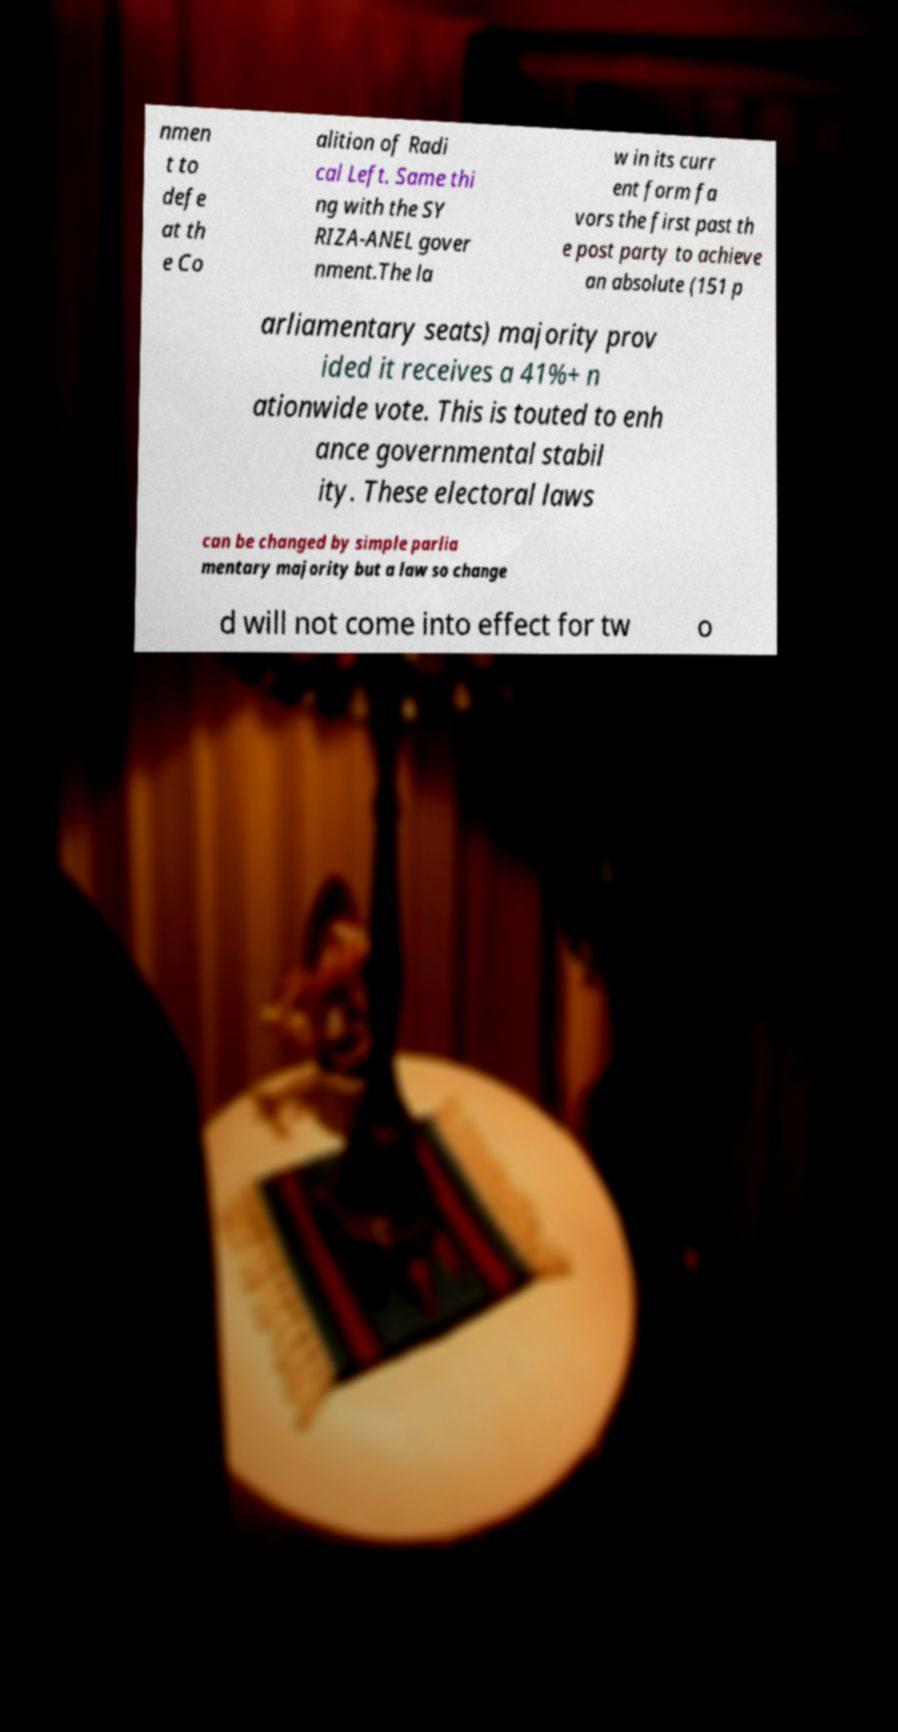Could you assist in decoding the text presented in this image and type it out clearly? nmen t to defe at th e Co alition of Radi cal Left. Same thi ng with the SY RIZA-ANEL gover nment.The la w in its curr ent form fa vors the first past th e post party to achieve an absolute (151 p arliamentary seats) majority prov ided it receives a 41%+ n ationwide vote. This is touted to enh ance governmental stabil ity. These electoral laws can be changed by simple parlia mentary majority but a law so change d will not come into effect for tw o 